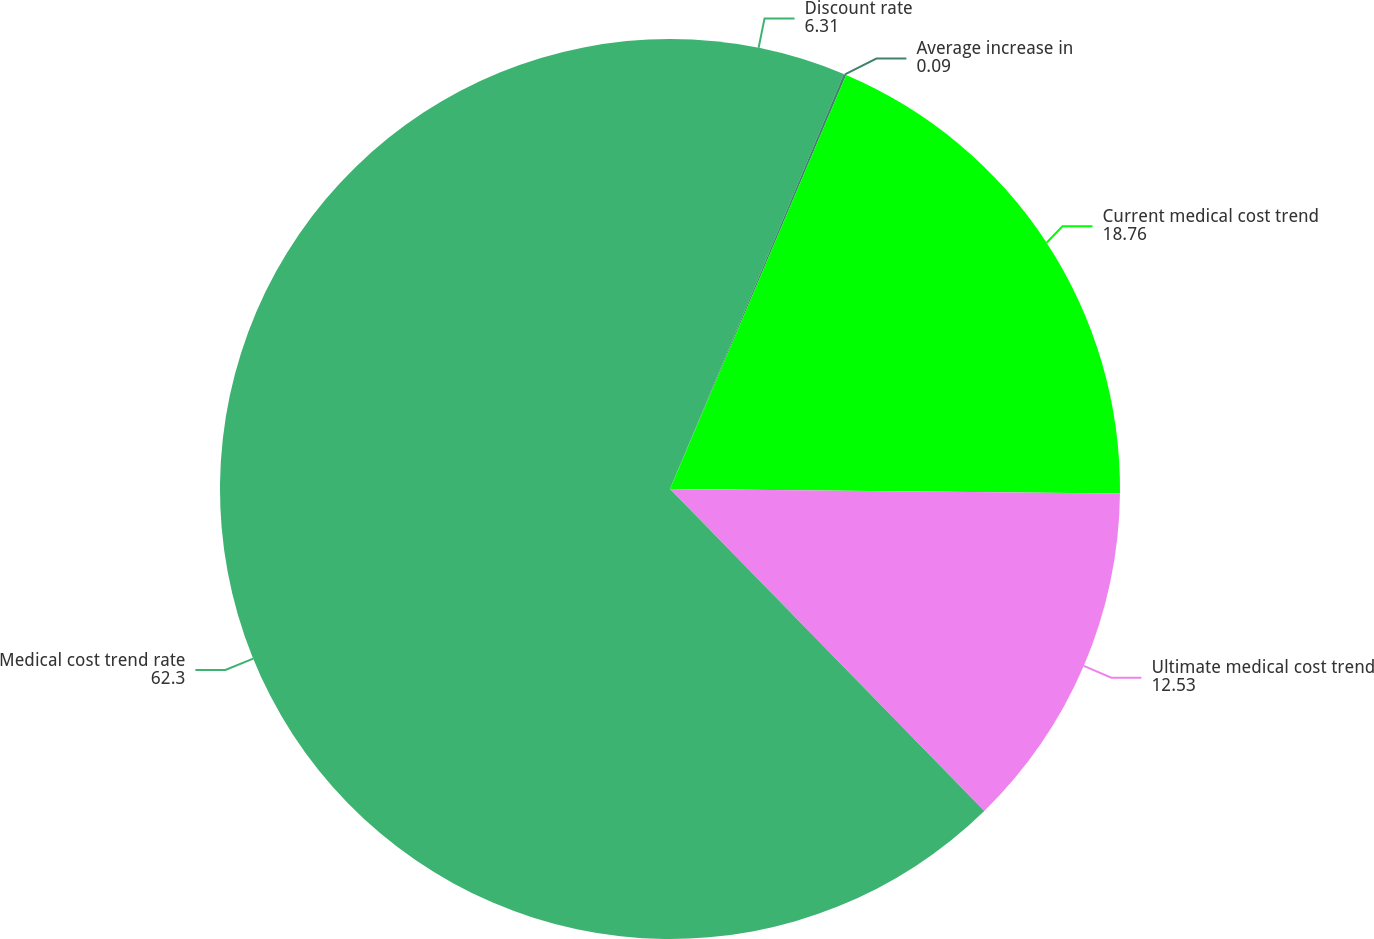Convert chart to OTSL. <chart><loc_0><loc_0><loc_500><loc_500><pie_chart><fcel>Discount rate<fcel>Average increase in<fcel>Current medical cost trend<fcel>Ultimate medical cost trend<fcel>Medical cost trend rate<nl><fcel>6.31%<fcel>0.09%<fcel>18.76%<fcel>12.53%<fcel>62.3%<nl></chart> 